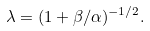Convert formula to latex. <formula><loc_0><loc_0><loc_500><loc_500>\lambda = ( 1 + \beta / \alpha ) ^ { - 1 / 2 } .</formula> 